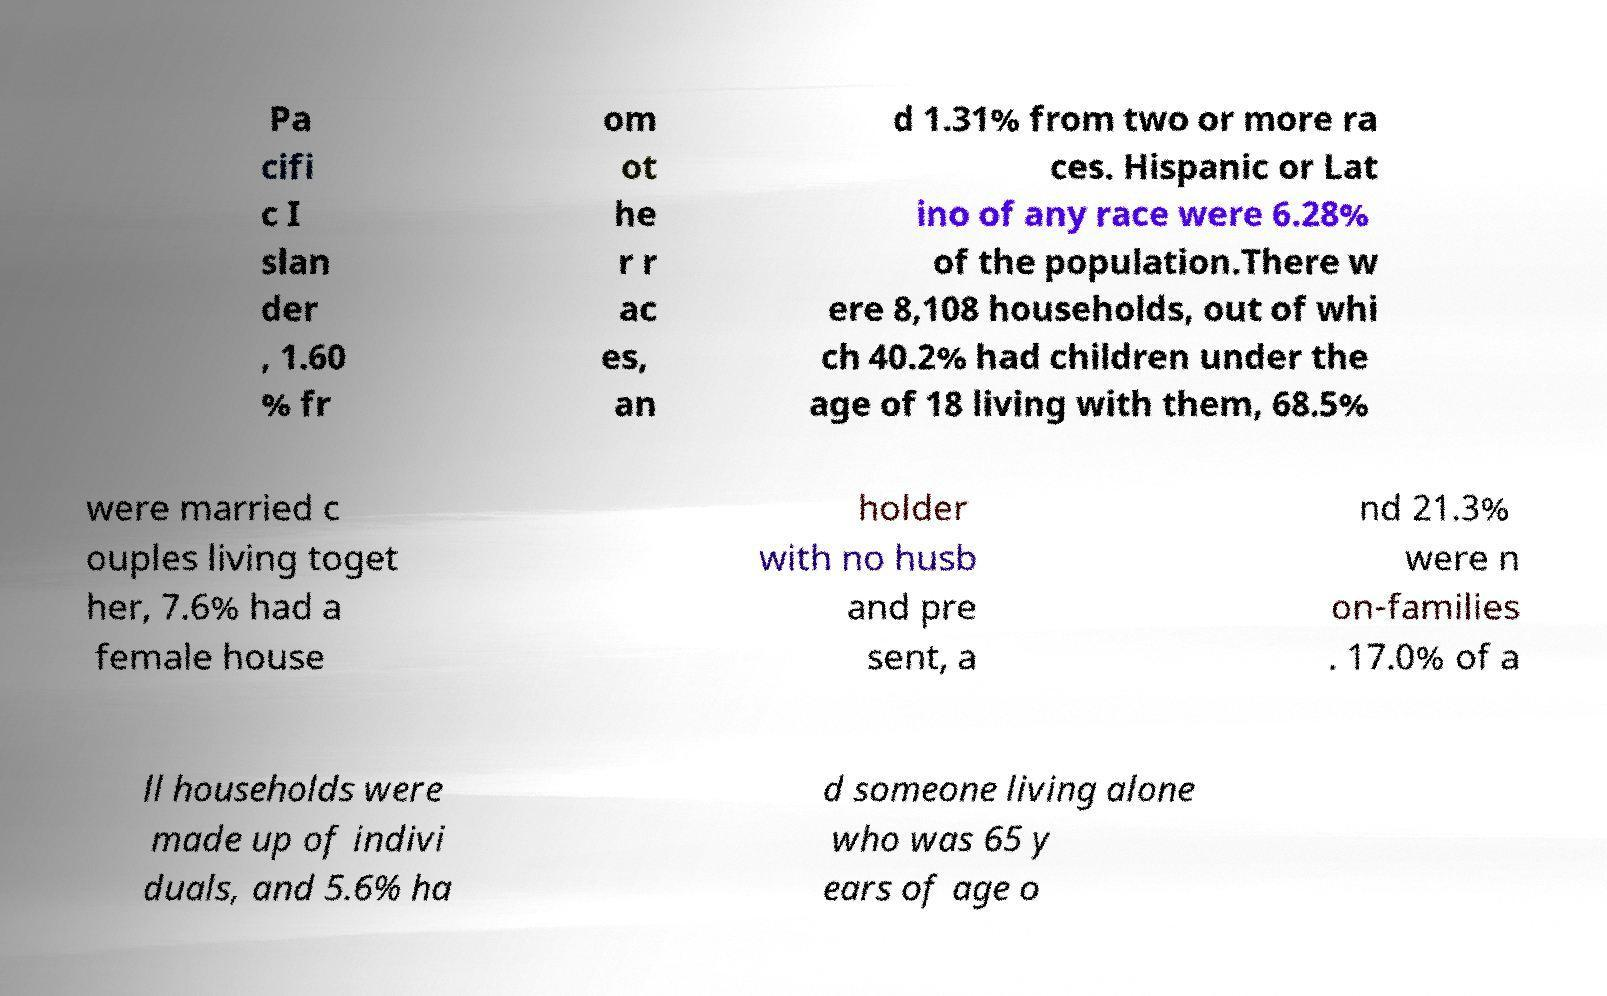For documentation purposes, I need the text within this image transcribed. Could you provide that? Pa cifi c I slan der , 1.60 % fr om ot he r r ac es, an d 1.31% from two or more ra ces. Hispanic or Lat ino of any race were 6.28% of the population.There w ere 8,108 households, out of whi ch 40.2% had children under the age of 18 living with them, 68.5% were married c ouples living toget her, 7.6% had a female house holder with no husb and pre sent, a nd 21.3% were n on-families . 17.0% of a ll households were made up of indivi duals, and 5.6% ha d someone living alone who was 65 y ears of age o 